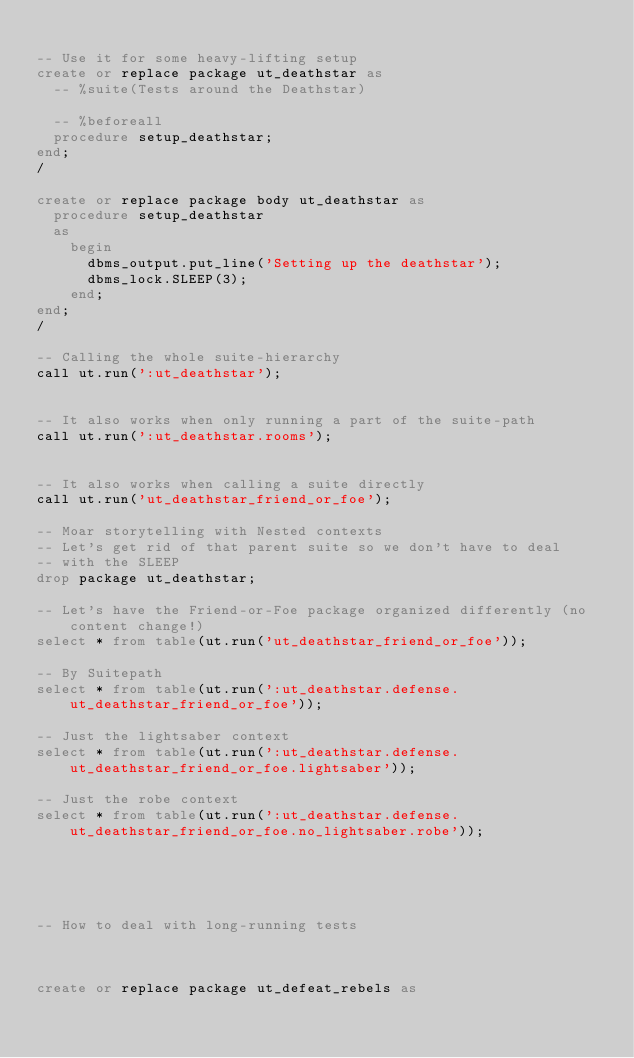Convert code to text. <code><loc_0><loc_0><loc_500><loc_500><_SQL_>
-- Use it for some heavy-lifting setup
create or replace package ut_deathstar as
  -- %suite(Tests around the Deathstar)

  -- %beforeall
  procedure setup_deathstar;
end;
/

create or replace package body ut_deathstar as
  procedure setup_deathstar
  as
    begin
      dbms_output.put_line('Setting up the deathstar');
      dbms_lock.SLEEP(3);
    end;
end;
/

-- Calling the whole suite-hierarchy
call ut.run(':ut_deathstar');


-- It also works when only running a part of the suite-path
call ut.run(':ut_deathstar.rooms');


-- It also works when calling a suite directly
call ut.run('ut_deathstar_friend_or_foe');

-- Moar storytelling with Nested contexts
-- Let's get rid of that parent suite so we don't have to deal
-- with the SLEEP
drop package ut_deathstar;

-- Let's have the Friend-or-Foe package organized differently (no content change!)
select * from table(ut.run('ut_deathstar_friend_or_foe'));

-- By Suitepath
select * from table(ut.run(':ut_deathstar.defense.ut_deathstar_friend_or_foe'));

-- Just the lightsaber context
select * from table(ut.run(':ut_deathstar.defense.ut_deathstar_friend_or_foe.lightsaber'));

-- Just the robe context
select * from table(ut.run(':ut_deathstar.defense.ut_deathstar_friend_or_foe.no_lightsaber.robe'));





-- How to deal with long-running tests



create or replace package ut_defeat_rebels as</code> 